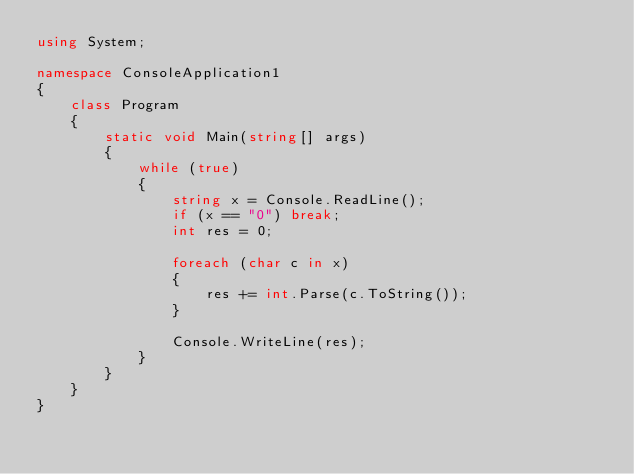Convert code to text. <code><loc_0><loc_0><loc_500><loc_500><_C#_>using System;

namespace ConsoleApplication1
{
    class Program
    {
        static void Main(string[] args)
        {
            while (true)
            {
                string x = Console.ReadLine();
                if (x == "0") break;
                int res = 0;

                foreach (char c in x)
                {
                    res += int.Parse(c.ToString());
                }

                Console.WriteLine(res);
            }
        }
    }
}</code> 